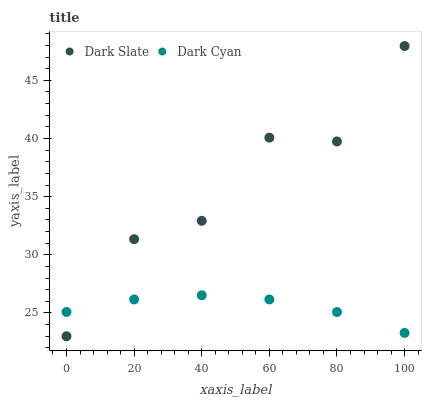Does Dark Cyan have the minimum area under the curve?
Answer yes or no. Yes. Does Dark Slate have the maximum area under the curve?
Answer yes or no. Yes. Does Dark Slate have the minimum area under the curve?
Answer yes or no. No. Is Dark Cyan the smoothest?
Answer yes or no. Yes. Is Dark Slate the roughest?
Answer yes or no. Yes. Is Dark Slate the smoothest?
Answer yes or no. No. Does Dark Slate have the lowest value?
Answer yes or no. Yes. Does Dark Slate have the highest value?
Answer yes or no. Yes. Does Dark Cyan intersect Dark Slate?
Answer yes or no. Yes. Is Dark Cyan less than Dark Slate?
Answer yes or no. No. Is Dark Cyan greater than Dark Slate?
Answer yes or no. No. 